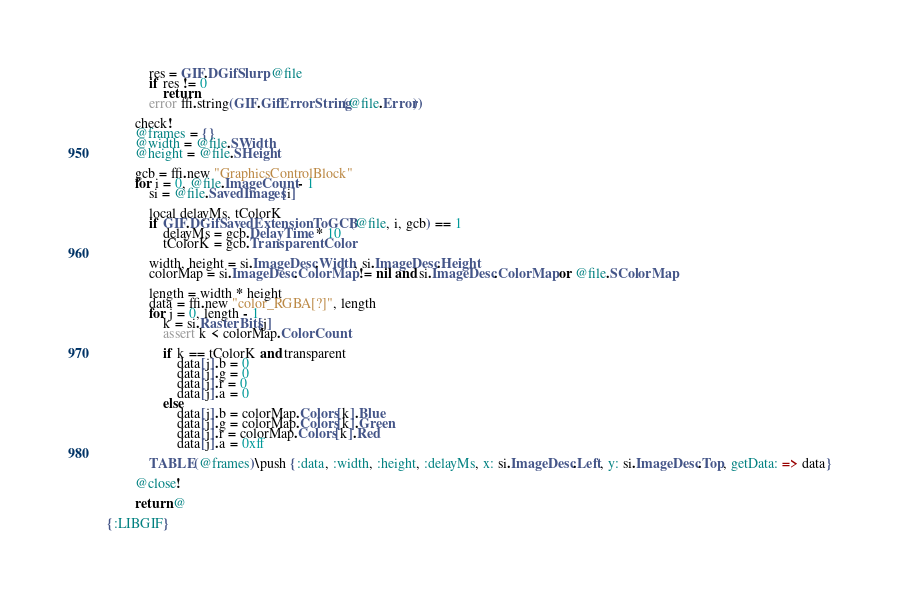Convert code to text. <code><loc_0><loc_0><loc_500><loc_500><_MoonScript_>            res = GIF.DGifSlurp @file
            if res != 0
                return
            error ffi.string(GIF.GifErrorString(@file.Error))

        check!
        @frames = {}
        @width = @file.SWidth
        @height = @file.SHeight

        gcb = ffi.new "GraphicsControlBlock"
        for i = 0, @file.ImageCount - 1
            si = @file.SavedImages[i]

            local delayMs, tColorK
            if GIF.DGifSavedExtensionToGCB(@file, i, gcb) == 1
                delayMs = gcb.DelayTime * 10
                tColorK = gcb.TransparentColor

            width, height = si.ImageDesc.Width, si.ImageDesc.Height
            colorMap = si.ImageDesc.ColorMap != nil and si.ImageDesc.ColorMap or @file.SColorMap

            length = width * height
            data = ffi.new "color_RGBA[?]", length
            for j = 0, length - 1
                k = si.RasterBits[j]
                assert k < colorMap.ColorCount

                if k == tColorK and transparent
                    data[j].b = 0
                    data[j].g = 0
                    data[j].r = 0
                    data[j].a = 0
                else
                    data[j].b = colorMap.Colors[k].Blue
                    data[j].g = colorMap.Colors[k].Green
                    data[j].r = colorMap.Colors[k].Red
                    data[j].a = 0xff

            TABLE(@frames)\push {:data, :width, :height, :delayMs, x: si.ImageDesc.Left, y: si.ImageDesc.Top, getData: => data}

        @close!

        return @

{:LIBGIF}</code> 